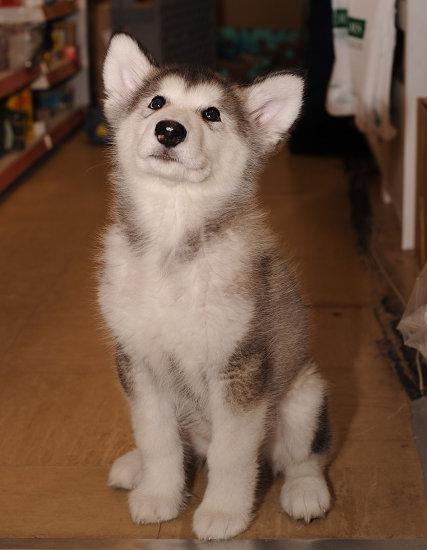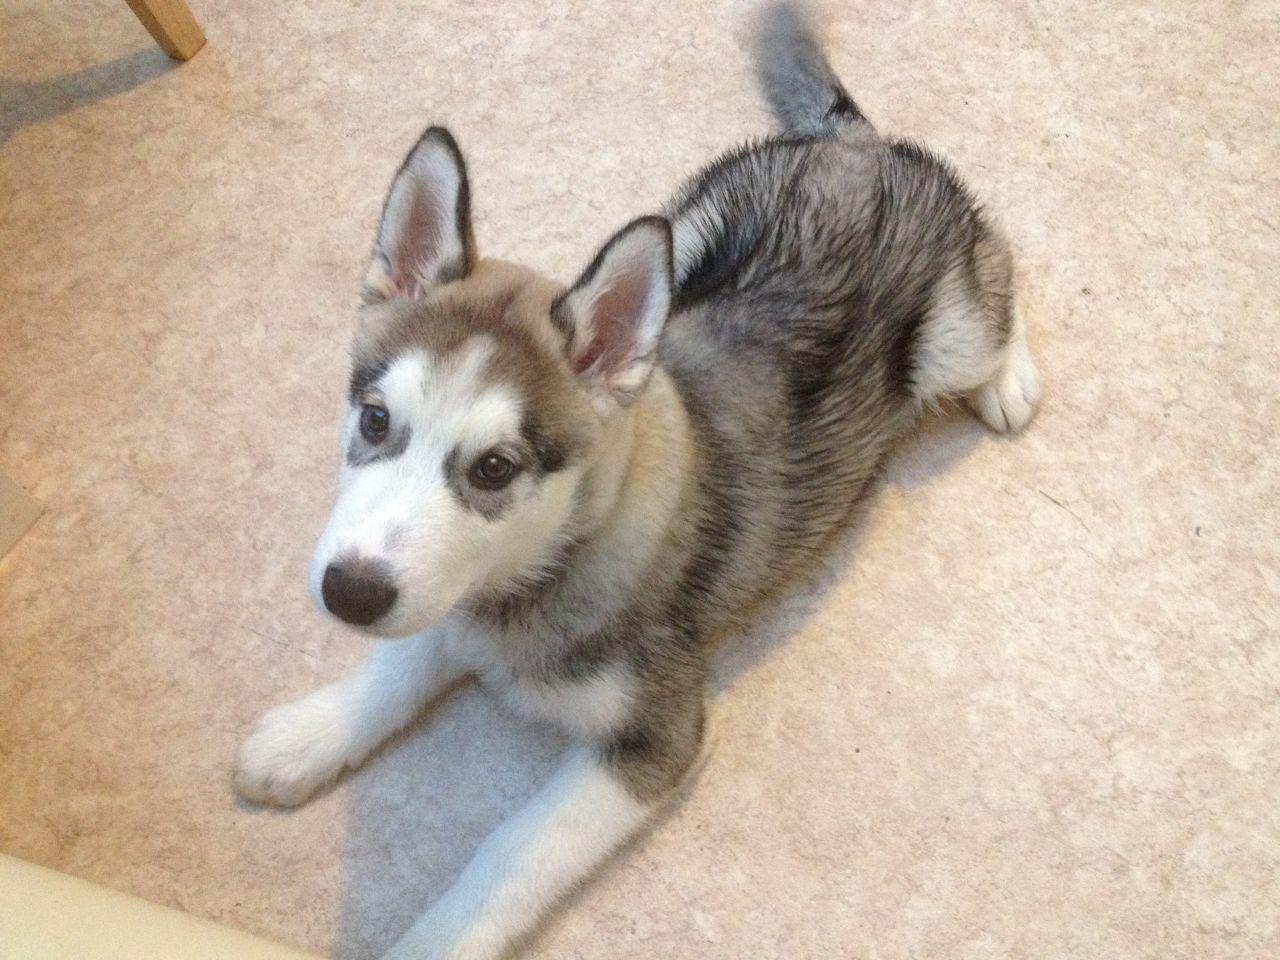The first image is the image on the left, the second image is the image on the right. Assess this claim about the two images: "Each image contains one husky pup with upright ears and muted fur coloring, and one image shows a puppy reclining with front paws extended on a mottled beige floor.". Correct or not? Answer yes or no. Yes. The first image is the image on the left, the second image is the image on the right. Considering the images on both sides, is "Neither of he images in the pair show an adult dog." valid? Answer yes or no. Yes. 